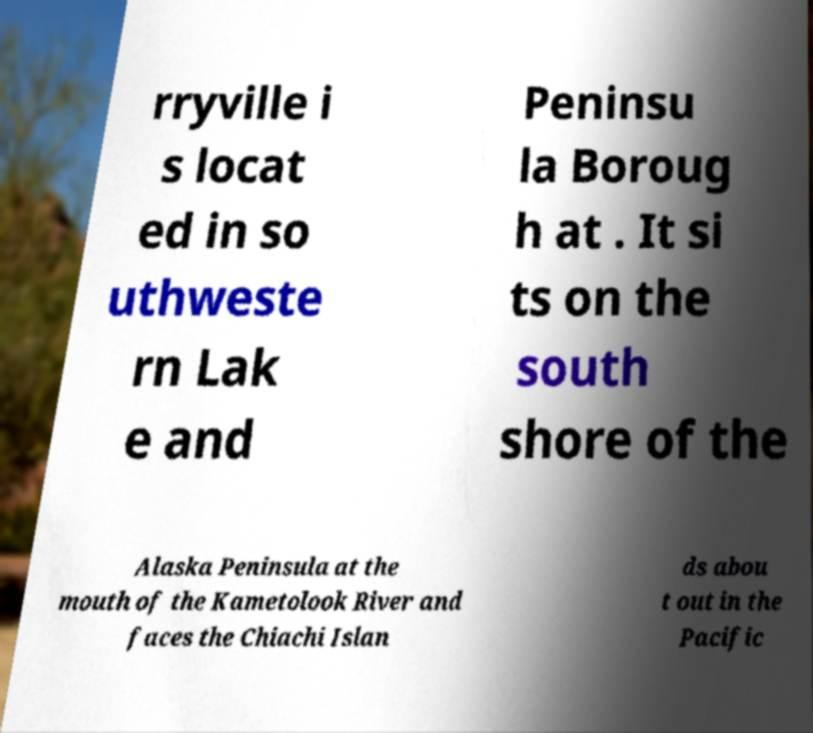For documentation purposes, I need the text within this image transcribed. Could you provide that? rryville i s locat ed in so uthweste rn Lak e and Peninsu la Boroug h at . It si ts on the south shore of the Alaska Peninsula at the mouth of the Kametolook River and faces the Chiachi Islan ds abou t out in the Pacific 